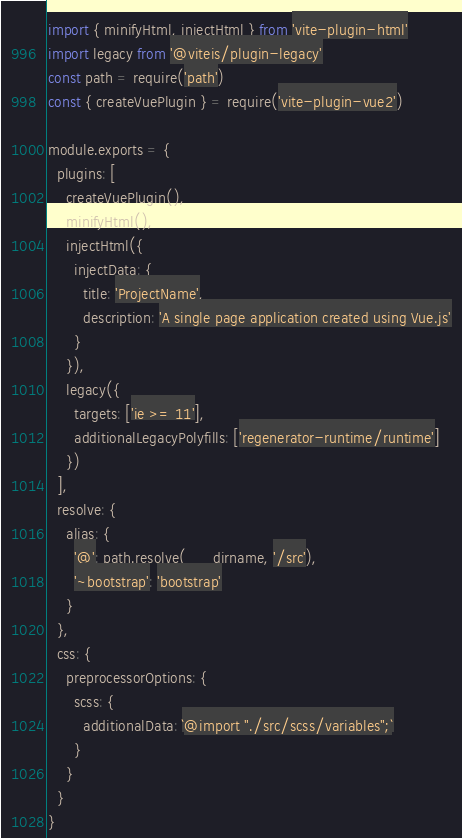<code> <loc_0><loc_0><loc_500><loc_500><_JavaScript_>import { minifyHtml, injectHtml } from 'vite-plugin-html'
import legacy from '@vitejs/plugin-legacy'
const path = require('path')
const { createVuePlugin } = require('vite-plugin-vue2')

module.exports = {
  plugins: [
    createVuePlugin(),
    minifyHtml(),
    injectHtml({
      injectData: {
        title: 'ProjectName',
        description: 'A single page application created using Vue.js'
      }
    }),
    legacy({
      targets: ['ie >= 11'],
      additionalLegacyPolyfills: ['regenerator-runtime/runtime']
    })
  ],
  resolve: {
    alias: {
      '@': path.resolve(__dirname, '/src'),
      '~bootstrap': 'bootstrap'
    }
  },
  css: {
    preprocessorOptions: {
      scss: {
        additionalData: `@import "./src/scss/variables";`
      }
    }
  }
}
</code> 